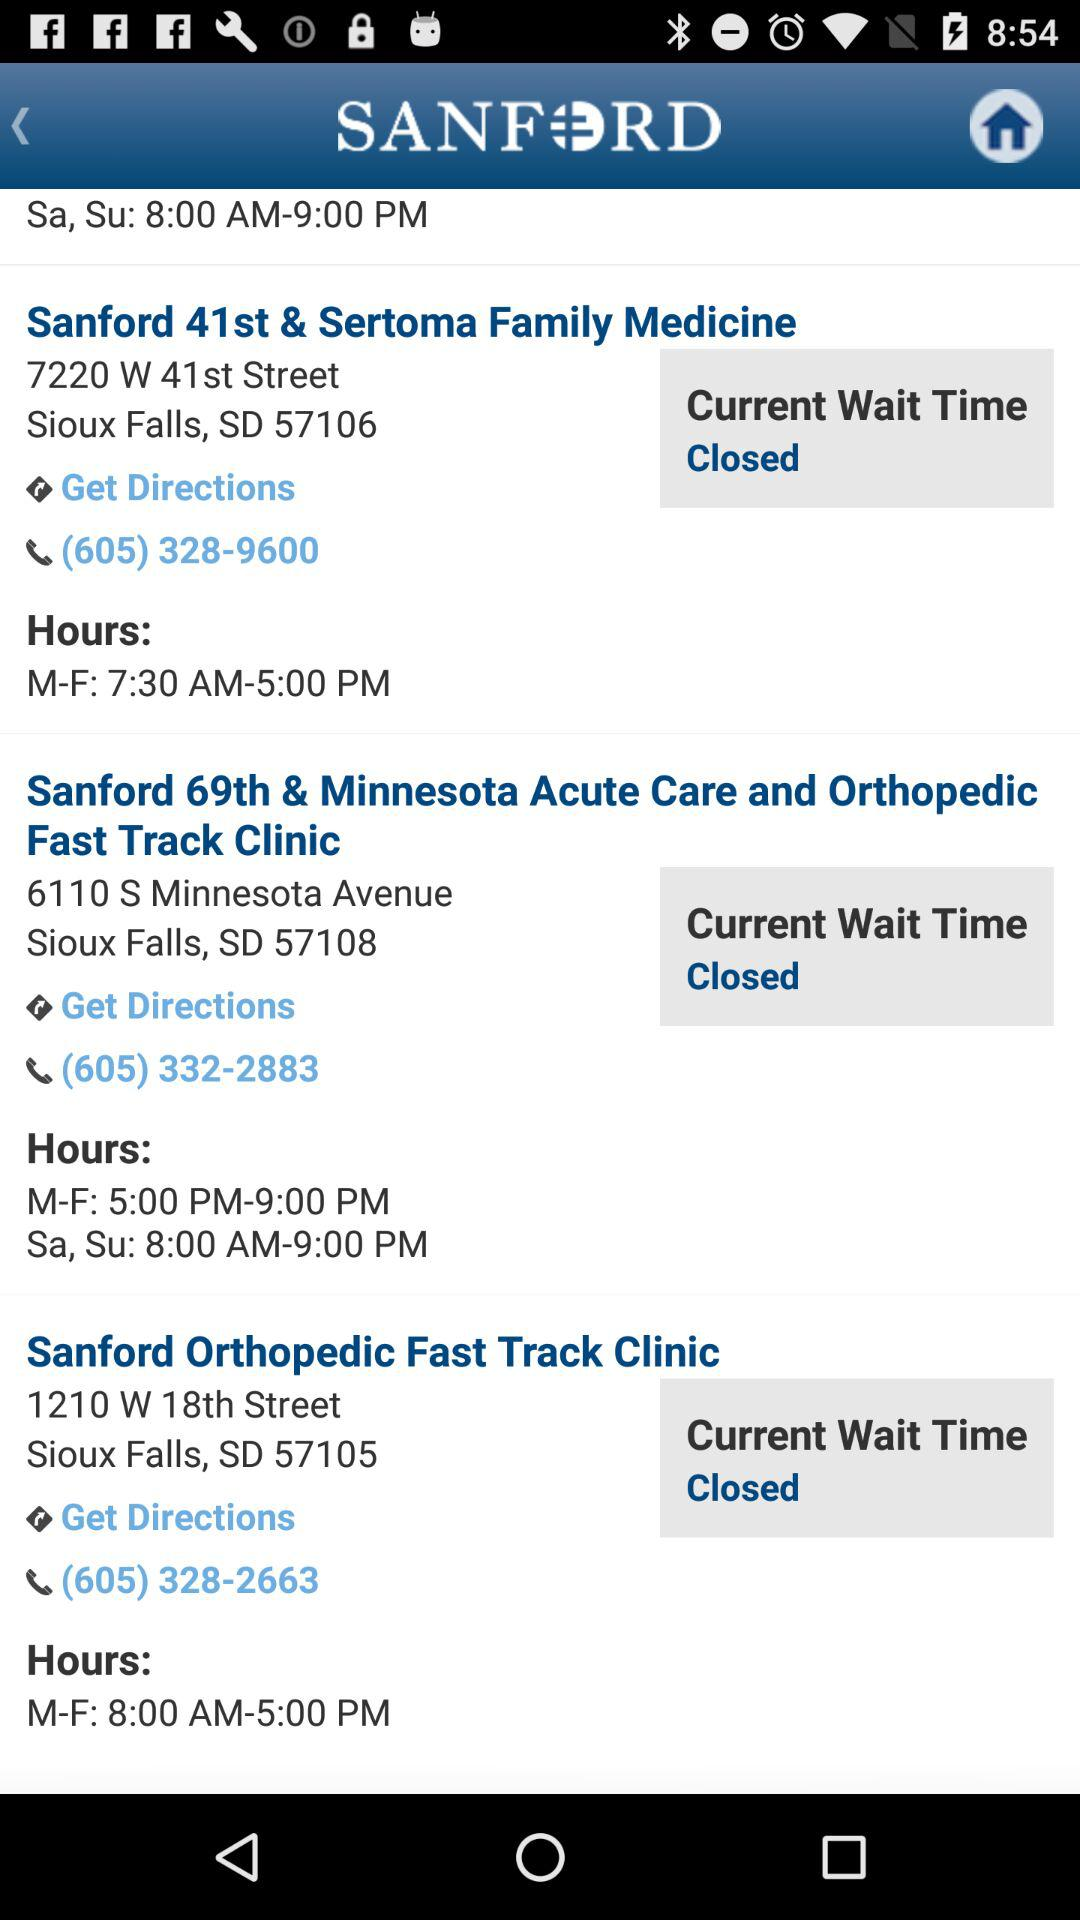What is the phone number for Sanford Orthopedic Fast Track Clinic? The phone number is (605) 328-2663. 